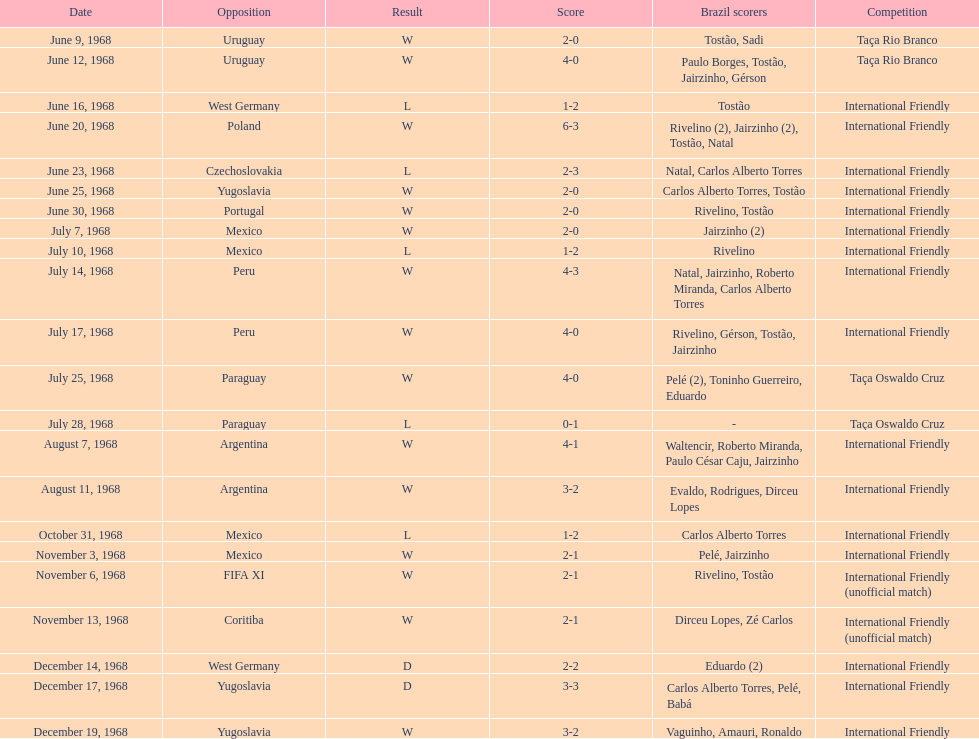In how many nations have they competed? 11. 